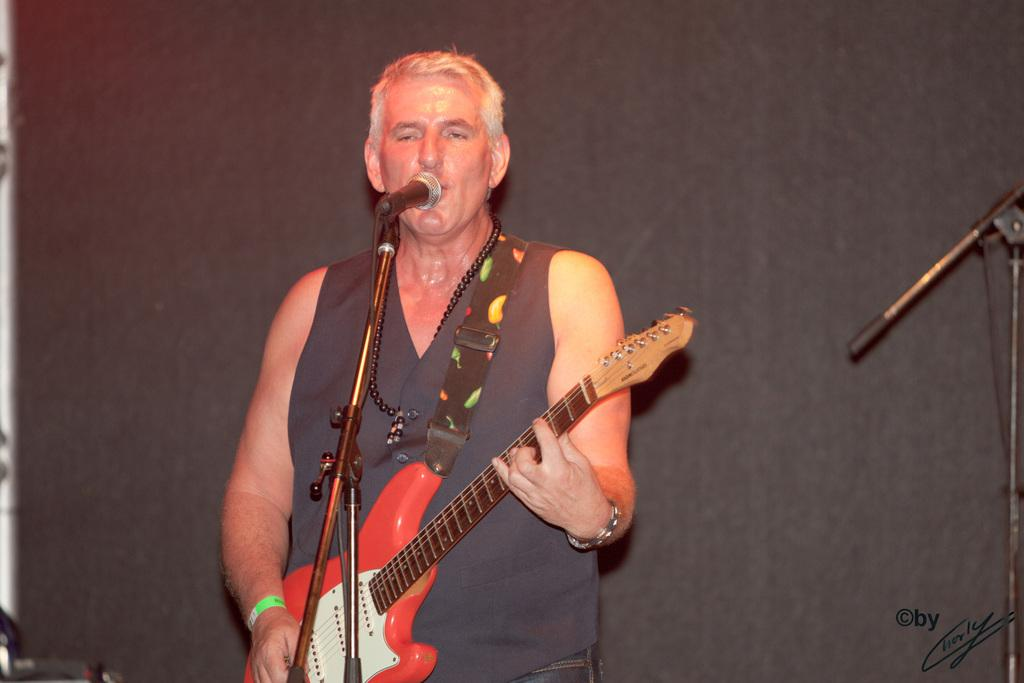What is the person in the image doing? The person is playing a guitar and singing a song. How is the person's voice being amplified in the image? The person is using a microphone. What type of structure can be seen in the background of the image? There is no structure visible in the background of the image. Can you see any crows in the image? There are no crows present in the image. 